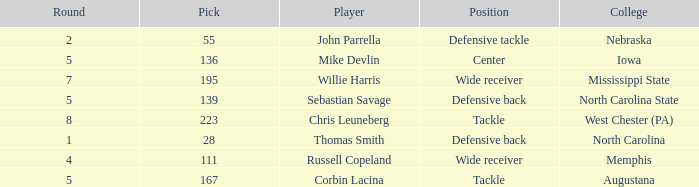What is the sum of Round with a Position that is center? 5.0. 